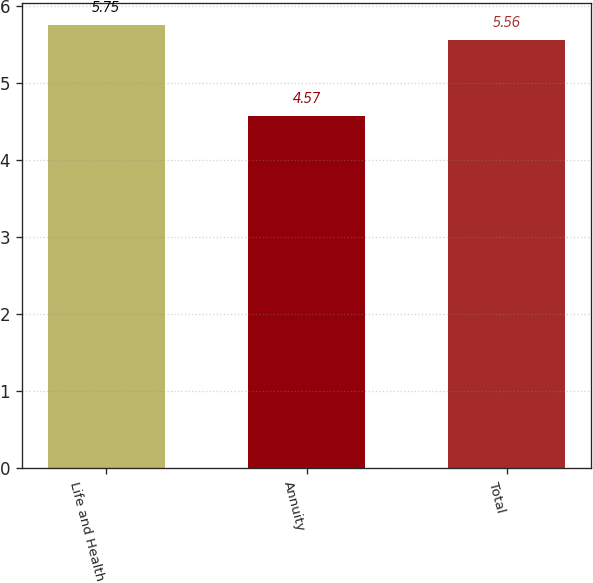Convert chart to OTSL. <chart><loc_0><loc_0><loc_500><loc_500><bar_chart><fcel>Life and Health<fcel>Annuity<fcel>Total<nl><fcel>5.75<fcel>4.57<fcel>5.56<nl></chart> 